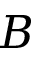Convert formula to latex. <formula><loc_0><loc_0><loc_500><loc_500>B</formula> 